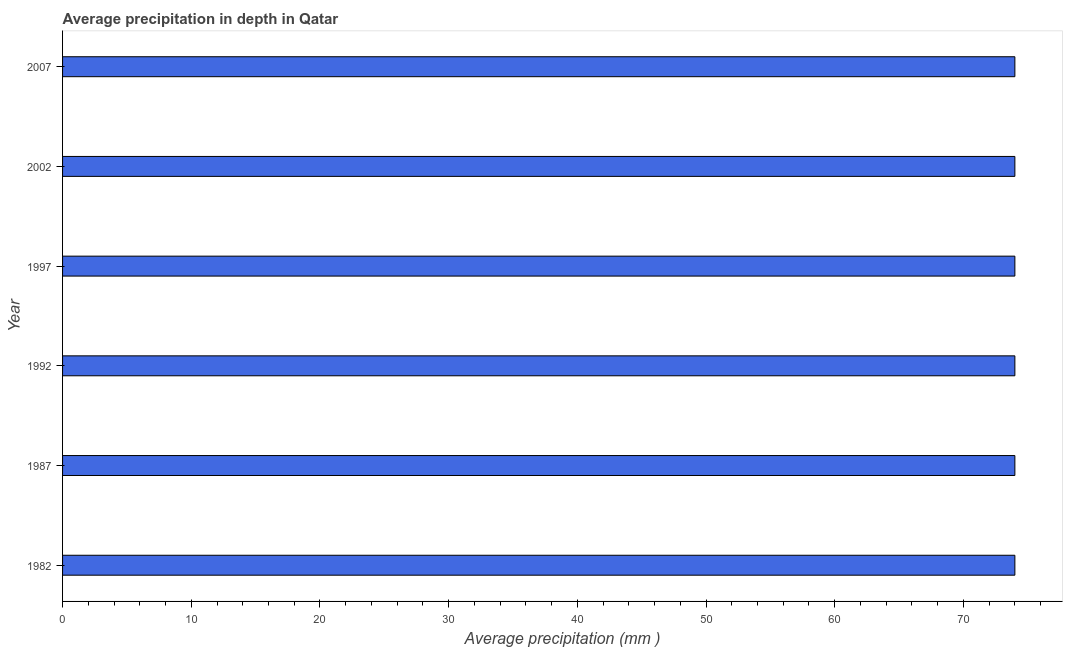What is the title of the graph?
Offer a terse response. Average precipitation in depth in Qatar. What is the label or title of the X-axis?
Ensure brevity in your answer.  Average precipitation (mm ). What is the label or title of the Y-axis?
Keep it short and to the point. Year. In which year was the average precipitation in depth maximum?
Your response must be concise. 1982. What is the sum of the average precipitation in depth?
Make the answer very short. 444. What is the difference between the average precipitation in depth in 1987 and 2002?
Make the answer very short. 0. What is the ratio of the average precipitation in depth in 1982 to that in 2007?
Make the answer very short. 1. Is the average precipitation in depth in 1997 less than that in 2007?
Ensure brevity in your answer.  No. Is the difference between the average precipitation in depth in 1987 and 2002 greater than the difference between any two years?
Ensure brevity in your answer.  Yes. Is the sum of the average precipitation in depth in 1997 and 2007 greater than the maximum average precipitation in depth across all years?
Provide a succinct answer. Yes. How many bars are there?
Provide a short and direct response. 6. How many years are there in the graph?
Your response must be concise. 6. What is the difference between two consecutive major ticks on the X-axis?
Ensure brevity in your answer.  10. Are the values on the major ticks of X-axis written in scientific E-notation?
Provide a succinct answer. No. What is the Average precipitation (mm ) of 1982?
Your response must be concise. 74. What is the Average precipitation (mm ) of 1997?
Your answer should be compact. 74. What is the Average precipitation (mm ) of 2007?
Provide a succinct answer. 74. What is the difference between the Average precipitation (mm ) in 1982 and 1987?
Your answer should be compact. 0. What is the difference between the Average precipitation (mm ) in 1982 and 1992?
Your answer should be compact. 0. What is the difference between the Average precipitation (mm ) in 1982 and 1997?
Provide a succinct answer. 0. What is the difference between the Average precipitation (mm ) in 1987 and 1992?
Keep it short and to the point. 0. What is the difference between the Average precipitation (mm ) in 1987 and 1997?
Your response must be concise. 0. What is the difference between the Average precipitation (mm ) in 1987 and 2002?
Offer a terse response. 0. What is the difference between the Average precipitation (mm ) in 1992 and 1997?
Offer a terse response. 0. What is the difference between the Average precipitation (mm ) in 1992 and 2007?
Keep it short and to the point. 0. What is the difference between the Average precipitation (mm ) in 1997 and 2007?
Make the answer very short. 0. What is the difference between the Average precipitation (mm ) in 2002 and 2007?
Give a very brief answer. 0. What is the ratio of the Average precipitation (mm ) in 1982 to that in 1992?
Your answer should be compact. 1. What is the ratio of the Average precipitation (mm ) in 1982 to that in 1997?
Provide a short and direct response. 1. What is the ratio of the Average precipitation (mm ) in 1982 to that in 2007?
Offer a very short reply. 1. What is the ratio of the Average precipitation (mm ) in 1987 to that in 1992?
Your answer should be very brief. 1. What is the ratio of the Average precipitation (mm ) in 1987 to that in 2002?
Your response must be concise. 1. What is the ratio of the Average precipitation (mm ) in 1992 to that in 1997?
Make the answer very short. 1. What is the ratio of the Average precipitation (mm ) in 1997 to that in 2002?
Ensure brevity in your answer.  1. What is the ratio of the Average precipitation (mm ) in 1997 to that in 2007?
Your answer should be very brief. 1. 